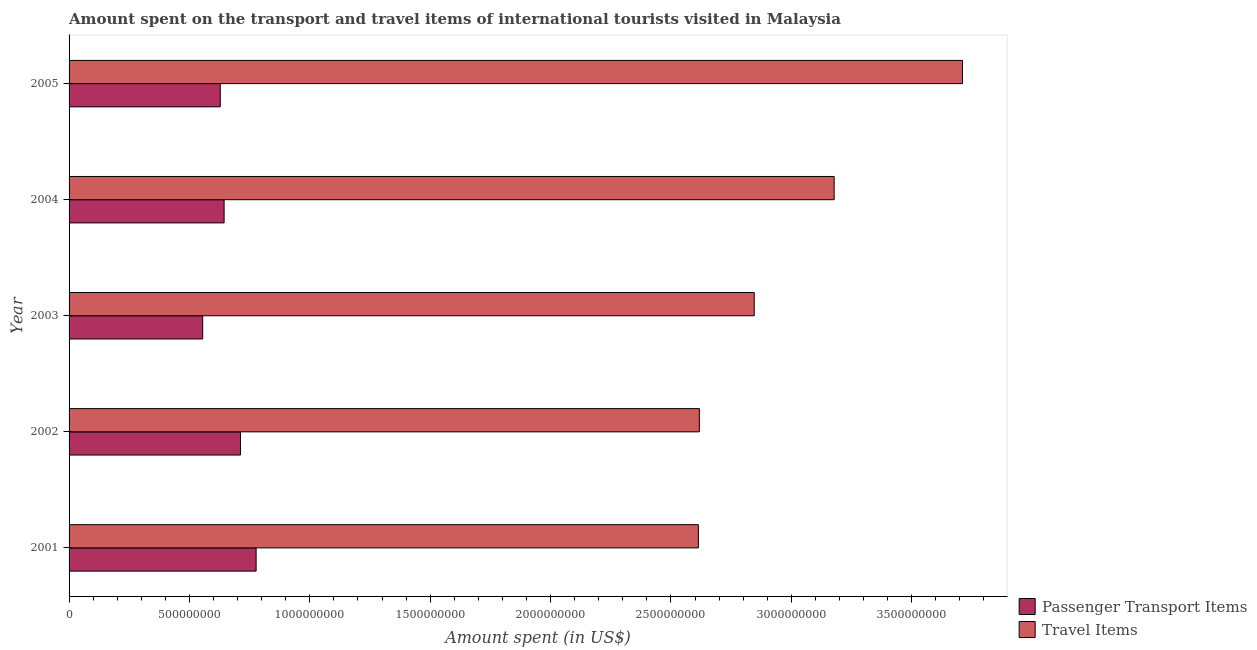How many groups of bars are there?
Make the answer very short. 5. Are the number of bars on each tick of the Y-axis equal?
Keep it short and to the point. Yes. How many bars are there on the 3rd tick from the top?
Your answer should be very brief. 2. How many bars are there on the 2nd tick from the bottom?
Give a very brief answer. 2. In how many cases, is the number of bars for a given year not equal to the number of legend labels?
Provide a short and direct response. 0. What is the amount spent in travel items in 2001?
Provide a short and direct response. 2.61e+09. Across all years, what is the maximum amount spent in travel items?
Ensure brevity in your answer.  3.71e+09. Across all years, what is the minimum amount spent in travel items?
Provide a succinct answer. 2.61e+09. In which year was the amount spent in travel items maximum?
Provide a short and direct response. 2005. In which year was the amount spent in travel items minimum?
Give a very brief answer. 2001. What is the total amount spent in travel items in the graph?
Keep it short and to the point. 1.50e+1. What is the difference between the amount spent on passenger transport items in 2003 and that in 2005?
Keep it short and to the point. -7.30e+07. What is the difference between the amount spent on passenger transport items in 2004 and the amount spent in travel items in 2002?
Provide a succinct answer. -1.97e+09. What is the average amount spent in travel items per year?
Offer a very short reply. 2.99e+09. In the year 2005, what is the difference between the amount spent on passenger transport items and amount spent in travel items?
Provide a succinct answer. -3.08e+09. What is the difference between the highest and the second highest amount spent on passenger transport items?
Ensure brevity in your answer.  6.50e+07. What is the difference between the highest and the lowest amount spent in travel items?
Provide a short and direct response. 1.10e+09. Is the sum of the amount spent in travel items in 2004 and 2005 greater than the maximum amount spent on passenger transport items across all years?
Your answer should be very brief. Yes. What does the 2nd bar from the top in 2004 represents?
Your response must be concise. Passenger Transport Items. What does the 1st bar from the bottom in 2003 represents?
Provide a succinct answer. Passenger Transport Items. How many years are there in the graph?
Offer a very short reply. 5. What is the difference between two consecutive major ticks on the X-axis?
Provide a short and direct response. 5.00e+08. Are the values on the major ticks of X-axis written in scientific E-notation?
Ensure brevity in your answer.  No. Does the graph contain any zero values?
Make the answer very short. No. Where does the legend appear in the graph?
Your response must be concise. Bottom right. What is the title of the graph?
Keep it short and to the point. Amount spent on the transport and travel items of international tourists visited in Malaysia. What is the label or title of the X-axis?
Provide a succinct answer. Amount spent (in US$). What is the label or title of the Y-axis?
Provide a succinct answer. Year. What is the Amount spent (in US$) in Passenger Transport Items in 2001?
Keep it short and to the point. 7.77e+08. What is the Amount spent (in US$) in Travel Items in 2001?
Offer a terse response. 2.61e+09. What is the Amount spent (in US$) of Passenger Transport Items in 2002?
Provide a short and direct response. 7.12e+08. What is the Amount spent (in US$) of Travel Items in 2002?
Keep it short and to the point. 2.62e+09. What is the Amount spent (in US$) in Passenger Transport Items in 2003?
Offer a very short reply. 5.55e+08. What is the Amount spent (in US$) in Travel Items in 2003?
Your response must be concise. 2.85e+09. What is the Amount spent (in US$) of Passenger Transport Items in 2004?
Provide a succinct answer. 6.44e+08. What is the Amount spent (in US$) in Travel Items in 2004?
Keep it short and to the point. 3.18e+09. What is the Amount spent (in US$) of Passenger Transport Items in 2005?
Offer a very short reply. 6.28e+08. What is the Amount spent (in US$) in Travel Items in 2005?
Keep it short and to the point. 3.71e+09. Across all years, what is the maximum Amount spent (in US$) in Passenger Transport Items?
Offer a terse response. 7.77e+08. Across all years, what is the maximum Amount spent (in US$) of Travel Items?
Your answer should be compact. 3.71e+09. Across all years, what is the minimum Amount spent (in US$) in Passenger Transport Items?
Provide a short and direct response. 5.55e+08. Across all years, what is the minimum Amount spent (in US$) of Travel Items?
Your answer should be compact. 2.61e+09. What is the total Amount spent (in US$) in Passenger Transport Items in the graph?
Provide a short and direct response. 3.32e+09. What is the total Amount spent (in US$) in Travel Items in the graph?
Your response must be concise. 1.50e+1. What is the difference between the Amount spent (in US$) of Passenger Transport Items in 2001 and that in 2002?
Provide a succinct answer. 6.50e+07. What is the difference between the Amount spent (in US$) of Travel Items in 2001 and that in 2002?
Make the answer very short. -4.00e+06. What is the difference between the Amount spent (in US$) of Passenger Transport Items in 2001 and that in 2003?
Provide a succinct answer. 2.22e+08. What is the difference between the Amount spent (in US$) of Travel Items in 2001 and that in 2003?
Your answer should be very brief. -2.32e+08. What is the difference between the Amount spent (in US$) of Passenger Transport Items in 2001 and that in 2004?
Offer a terse response. 1.33e+08. What is the difference between the Amount spent (in US$) in Travel Items in 2001 and that in 2004?
Give a very brief answer. -5.64e+08. What is the difference between the Amount spent (in US$) of Passenger Transport Items in 2001 and that in 2005?
Give a very brief answer. 1.49e+08. What is the difference between the Amount spent (in US$) in Travel Items in 2001 and that in 2005?
Ensure brevity in your answer.  -1.10e+09. What is the difference between the Amount spent (in US$) of Passenger Transport Items in 2002 and that in 2003?
Provide a succinct answer. 1.57e+08. What is the difference between the Amount spent (in US$) in Travel Items in 2002 and that in 2003?
Keep it short and to the point. -2.28e+08. What is the difference between the Amount spent (in US$) in Passenger Transport Items in 2002 and that in 2004?
Provide a short and direct response. 6.80e+07. What is the difference between the Amount spent (in US$) of Travel Items in 2002 and that in 2004?
Give a very brief answer. -5.60e+08. What is the difference between the Amount spent (in US$) of Passenger Transport Items in 2002 and that in 2005?
Keep it short and to the point. 8.40e+07. What is the difference between the Amount spent (in US$) in Travel Items in 2002 and that in 2005?
Your answer should be compact. -1.09e+09. What is the difference between the Amount spent (in US$) of Passenger Transport Items in 2003 and that in 2004?
Give a very brief answer. -8.90e+07. What is the difference between the Amount spent (in US$) of Travel Items in 2003 and that in 2004?
Your answer should be very brief. -3.32e+08. What is the difference between the Amount spent (in US$) in Passenger Transport Items in 2003 and that in 2005?
Offer a very short reply. -7.30e+07. What is the difference between the Amount spent (in US$) in Travel Items in 2003 and that in 2005?
Your response must be concise. -8.65e+08. What is the difference between the Amount spent (in US$) in Passenger Transport Items in 2004 and that in 2005?
Offer a very short reply. 1.60e+07. What is the difference between the Amount spent (in US$) in Travel Items in 2004 and that in 2005?
Provide a short and direct response. -5.33e+08. What is the difference between the Amount spent (in US$) of Passenger Transport Items in 2001 and the Amount spent (in US$) of Travel Items in 2002?
Keep it short and to the point. -1.84e+09. What is the difference between the Amount spent (in US$) of Passenger Transport Items in 2001 and the Amount spent (in US$) of Travel Items in 2003?
Ensure brevity in your answer.  -2.07e+09. What is the difference between the Amount spent (in US$) of Passenger Transport Items in 2001 and the Amount spent (in US$) of Travel Items in 2004?
Give a very brief answer. -2.40e+09. What is the difference between the Amount spent (in US$) of Passenger Transport Items in 2001 and the Amount spent (in US$) of Travel Items in 2005?
Keep it short and to the point. -2.93e+09. What is the difference between the Amount spent (in US$) in Passenger Transport Items in 2002 and the Amount spent (in US$) in Travel Items in 2003?
Your answer should be very brief. -2.13e+09. What is the difference between the Amount spent (in US$) in Passenger Transport Items in 2002 and the Amount spent (in US$) in Travel Items in 2004?
Your answer should be very brief. -2.47e+09. What is the difference between the Amount spent (in US$) of Passenger Transport Items in 2002 and the Amount spent (in US$) of Travel Items in 2005?
Your response must be concise. -3.00e+09. What is the difference between the Amount spent (in US$) in Passenger Transport Items in 2003 and the Amount spent (in US$) in Travel Items in 2004?
Provide a short and direct response. -2.62e+09. What is the difference between the Amount spent (in US$) of Passenger Transport Items in 2003 and the Amount spent (in US$) of Travel Items in 2005?
Make the answer very short. -3.16e+09. What is the difference between the Amount spent (in US$) in Passenger Transport Items in 2004 and the Amount spent (in US$) in Travel Items in 2005?
Keep it short and to the point. -3.07e+09. What is the average Amount spent (in US$) of Passenger Transport Items per year?
Provide a succinct answer. 6.63e+08. What is the average Amount spent (in US$) in Travel Items per year?
Keep it short and to the point. 2.99e+09. In the year 2001, what is the difference between the Amount spent (in US$) in Passenger Transport Items and Amount spent (in US$) in Travel Items?
Your answer should be compact. -1.84e+09. In the year 2002, what is the difference between the Amount spent (in US$) of Passenger Transport Items and Amount spent (in US$) of Travel Items?
Offer a terse response. -1.91e+09. In the year 2003, what is the difference between the Amount spent (in US$) of Passenger Transport Items and Amount spent (in US$) of Travel Items?
Give a very brief answer. -2.29e+09. In the year 2004, what is the difference between the Amount spent (in US$) in Passenger Transport Items and Amount spent (in US$) in Travel Items?
Offer a very short reply. -2.53e+09. In the year 2005, what is the difference between the Amount spent (in US$) of Passenger Transport Items and Amount spent (in US$) of Travel Items?
Provide a short and direct response. -3.08e+09. What is the ratio of the Amount spent (in US$) of Passenger Transport Items in 2001 to that in 2002?
Provide a short and direct response. 1.09. What is the ratio of the Amount spent (in US$) in Travel Items in 2001 to that in 2002?
Provide a succinct answer. 1. What is the ratio of the Amount spent (in US$) of Passenger Transport Items in 2001 to that in 2003?
Offer a terse response. 1.4. What is the ratio of the Amount spent (in US$) in Travel Items in 2001 to that in 2003?
Offer a terse response. 0.92. What is the ratio of the Amount spent (in US$) of Passenger Transport Items in 2001 to that in 2004?
Give a very brief answer. 1.21. What is the ratio of the Amount spent (in US$) of Travel Items in 2001 to that in 2004?
Provide a succinct answer. 0.82. What is the ratio of the Amount spent (in US$) of Passenger Transport Items in 2001 to that in 2005?
Give a very brief answer. 1.24. What is the ratio of the Amount spent (in US$) in Travel Items in 2001 to that in 2005?
Ensure brevity in your answer.  0.7. What is the ratio of the Amount spent (in US$) of Passenger Transport Items in 2002 to that in 2003?
Provide a short and direct response. 1.28. What is the ratio of the Amount spent (in US$) in Travel Items in 2002 to that in 2003?
Keep it short and to the point. 0.92. What is the ratio of the Amount spent (in US$) of Passenger Transport Items in 2002 to that in 2004?
Your answer should be compact. 1.11. What is the ratio of the Amount spent (in US$) in Travel Items in 2002 to that in 2004?
Give a very brief answer. 0.82. What is the ratio of the Amount spent (in US$) of Passenger Transport Items in 2002 to that in 2005?
Your answer should be very brief. 1.13. What is the ratio of the Amount spent (in US$) in Travel Items in 2002 to that in 2005?
Your response must be concise. 0.71. What is the ratio of the Amount spent (in US$) in Passenger Transport Items in 2003 to that in 2004?
Give a very brief answer. 0.86. What is the ratio of the Amount spent (in US$) in Travel Items in 2003 to that in 2004?
Make the answer very short. 0.9. What is the ratio of the Amount spent (in US$) in Passenger Transport Items in 2003 to that in 2005?
Your response must be concise. 0.88. What is the ratio of the Amount spent (in US$) of Travel Items in 2003 to that in 2005?
Offer a terse response. 0.77. What is the ratio of the Amount spent (in US$) of Passenger Transport Items in 2004 to that in 2005?
Provide a succinct answer. 1.03. What is the ratio of the Amount spent (in US$) in Travel Items in 2004 to that in 2005?
Keep it short and to the point. 0.86. What is the difference between the highest and the second highest Amount spent (in US$) of Passenger Transport Items?
Give a very brief answer. 6.50e+07. What is the difference between the highest and the second highest Amount spent (in US$) of Travel Items?
Offer a very short reply. 5.33e+08. What is the difference between the highest and the lowest Amount spent (in US$) in Passenger Transport Items?
Keep it short and to the point. 2.22e+08. What is the difference between the highest and the lowest Amount spent (in US$) of Travel Items?
Your response must be concise. 1.10e+09. 